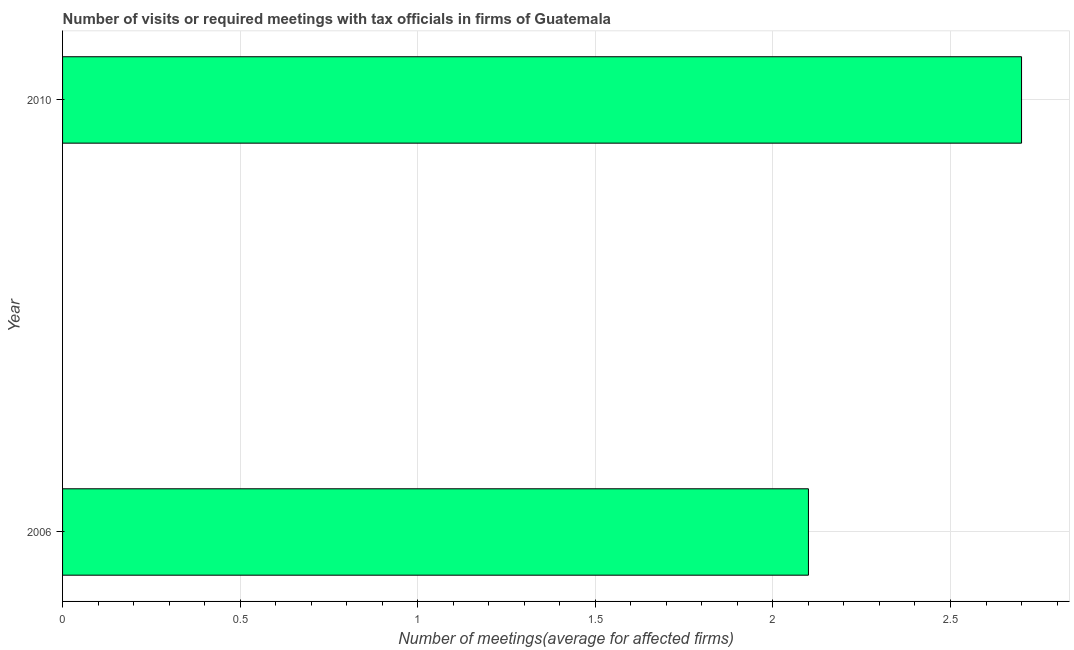Does the graph contain any zero values?
Your answer should be very brief. No. Does the graph contain grids?
Your response must be concise. Yes. What is the title of the graph?
Keep it short and to the point. Number of visits or required meetings with tax officials in firms of Guatemala. What is the label or title of the X-axis?
Offer a very short reply. Number of meetings(average for affected firms). What is the number of required meetings with tax officials in 2006?
Provide a short and direct response. 2.1. Across all years, what is the maximum number of required meetings with tax officials?
Ensure brevity in your answer.  2.7. What is the sum of the number of required meetings with tax officials?
Your answer should be compact. 4.8. What is the average number of required meetings with tax officials per year?
Provide a succinct answer. 2.4. What is the median number of required meetings with tax officials?
Keep it short and to the point. 2.4. Do a majority of the years between 2006 and 2010 (inclusive) have number of required meetings with tax officials greater than 1.6 ?
Your response must be concise. Yes. What is the ratio of the number of required meetings with tax officials in 2006 to that in 2010?
Your answer should be very brief. 0.78. Is the number of required meetings with tax officials in 2006 less than that in 2010?
Offer a very short reply. Yes. In how many years, is the number of required meetings with tax officials greater than the average number of required meetings with tax officials taken over all years?
Your response must be concise. 1. How many years are there in the graph?
Offer a terse response. 2. Are the values on the major ticks of X-axis written in scientific E-notation?
Your answer should be compact. No. What is the Number of meetings(average for affected firms) in 2006?
Provide a short and direct response. 2.1. What is the difference between the Number of meetings(average for affected firms) in 2006 and 2010?
Provide a short and direct response. -0.6. What is the ratio of the Number of meetings(average for affected firms) in 2006 to that in 2010?
Give a very brief answer. 0.78. 